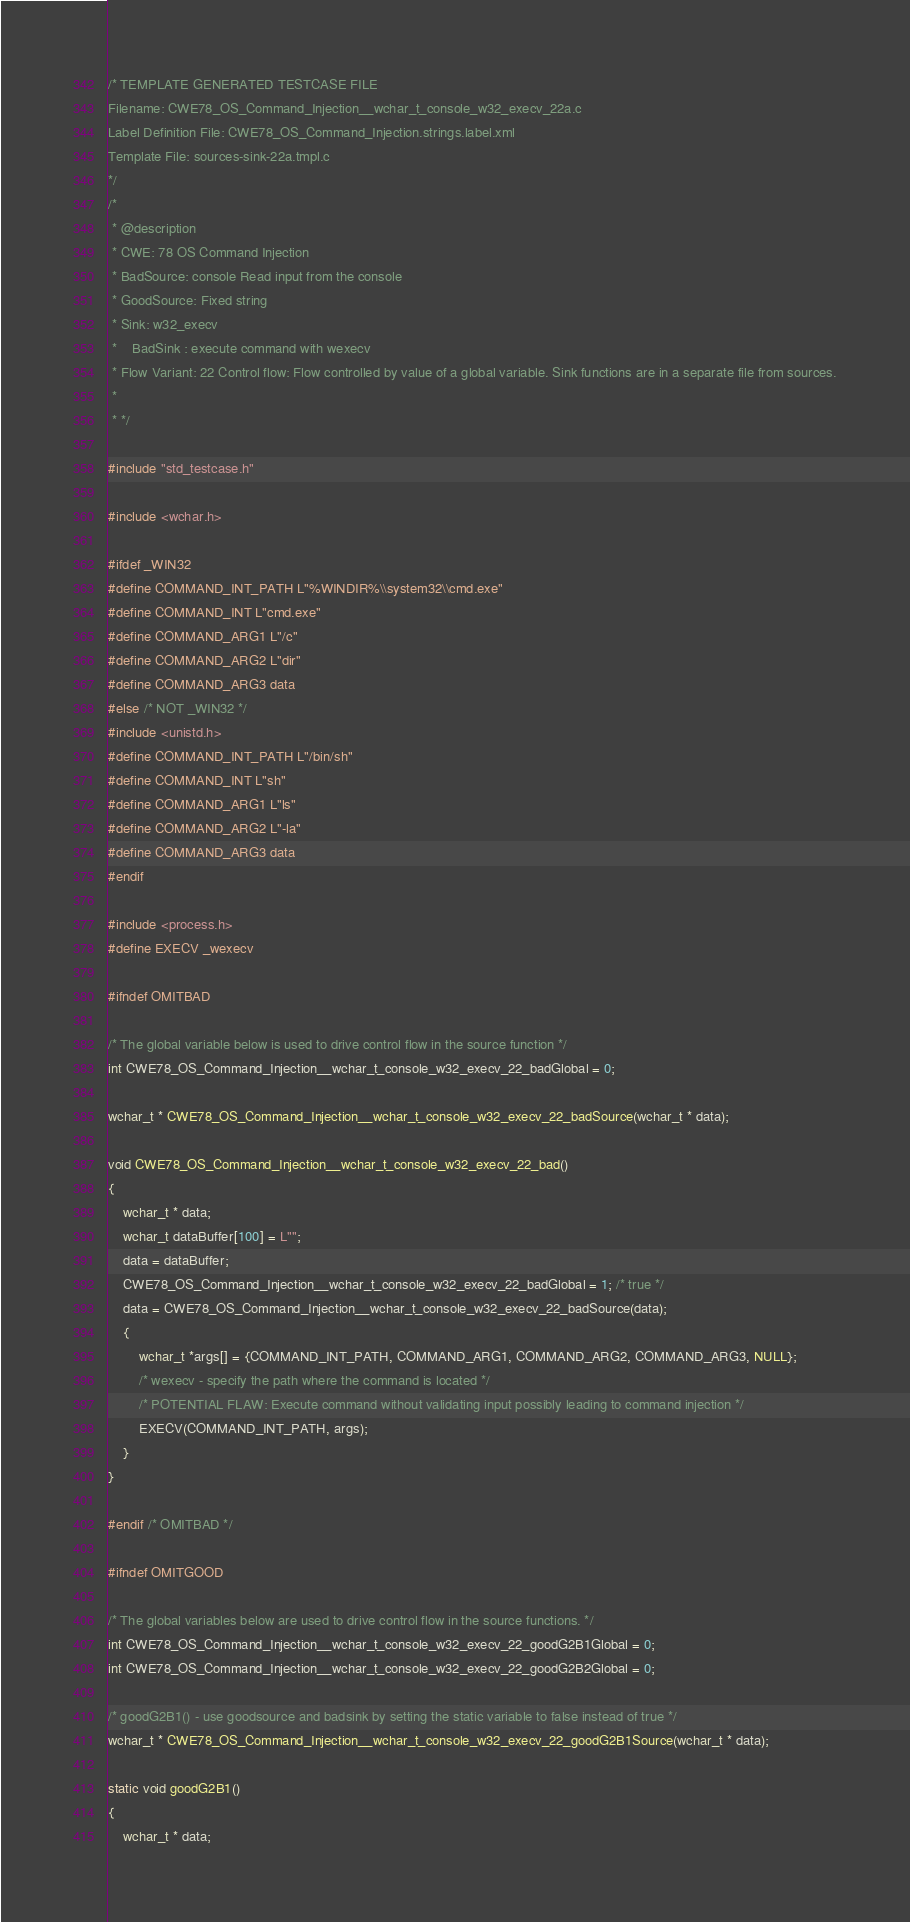<code> <loc_0><loc_0><loc_500><loc_500><_C_>/* TEMPLATE GENERATED TESTCASE FILE
Filename: CWE78_OS_Command_Injection__wchar_t_console_w32_execv_22a.c
Label Definition File: CWE78_OS_Command_Injection.strings.label.xml
Template File: sources-sink-22a.tmpl.c
*/
/*
 * @description
 * CWE: 78 OS Command Injection
 * BadSource: console Read input from the console
 * GoodSource: Fixed string
 * Sink: w32_execv
 *    BadSink : execute command with wexecv
 * Flow Variant: 22 Control flow: Flow controlled by value of a global variable. Sink functions are in a separate file from sources.
 *
 * */

#include "std_testcase.h"

#include <wchar.h>

#ifdef _WIN32
#define COMMAND_INT_PATH L"%WINDIR%\\system32\\cmd.exe"
#define COMMAND_INT L"cmd.exe"
#define COMMAND_ARG1 L"/c"
#define COMMAND_ARG2 L"dir"
#define COMMAND_ARG3 data
#else /* NOT _WIN32 */
#include <unistd.h>
#define COMMAND_INT_PATH L"/bin/sh"
#define COMMAND_INT L"sh"
#define COMMAND_ARG1 L"ls"
#define COMMAND_ARG2 L"-la"
#define COMMAND_ARG3 data
#endif

#include <process.h>
#define EXECV _wexecv

#ifndef OMITBAD

/* The global variable below is used to drive control flow in the source function */
int CWE78_OS_Command_Injection__wchar_t_console_w32_execv_22_badGlobal = 0;

wchar_t * CWE78_OS_Command_Injection__wchar_t_console_w32_execv_22_badSource(wchar_t * data);

void CWE78_OS_Command_Injection__wchar_t_console_w32_execv_22_bad()
{
    wchar_t * data;
    wchar_t dataBuffer[100] = L"";
    data = dataBuffer;
    CWE78_OS_Command_Injection__wchar_t_console_w32_execv_22_badGlobal = 1; /* true */
    data = CWE78_OS_Command_Injection__wchar_t_console_w32_execv_22_badSource(data);
    {
        wchar_t *args[] = {COMMAND_INT_PATH, COMMAND_ARG1, COMMAND_ARG2, COMMAND_ARG3, NULL};
        /* wexecv - specify the path where the command is located */
        /* POTENTIAL FLAW: Execute command without validating input possibly leading to command injection */
        EXECV(COMMAND_INT_PATH, args);
    }
}

#endif /* OMITBAD */

#ifndef OMITGOOD

/* The global variables below are used to drive control flow in the source functions. */
int CWE78_OS_Command_Injection__wchar_t_console_w32_execv_22_goodG2B1Global = 0;
int CWE78_OS_Command_Injection__wchar_t_console_w32_execv_22_goodG2B2Global = 0;

/* goodG2B1() - use goodsource and badsink by setting the static variable to false instead of true */
wchar_t * CWE78_OS_Command_Injection__wchar_t_console_w32_execv_22_goodG2B1Source(wchar_t * data);

static void goodG2B1()
{
    wchar_t * data;</code> 